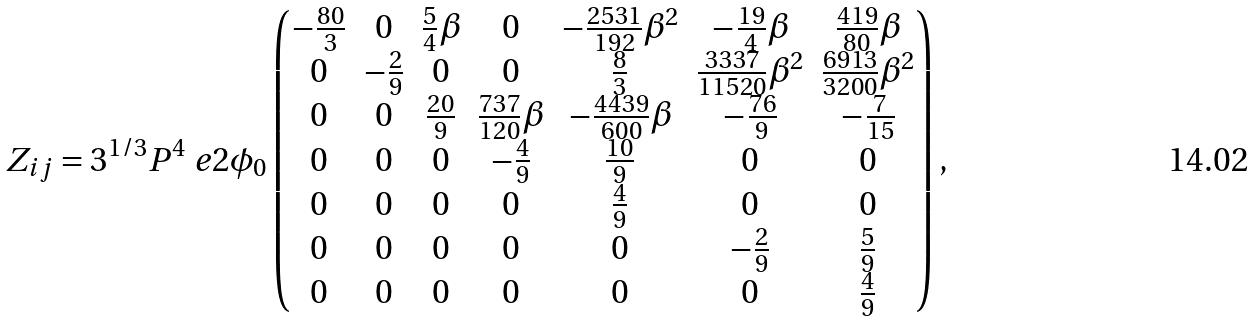Convert formula to latex. <formula><loc_0><loc_0><loc_500><loc_500>Z _ { i j } = 3 ^ { 1 / 3 } P ^ { 4 } \ e { 2 \phi _ { 0 } } \begin{pmatrix} - \frac { 8 0 } { 3 } & 0 & \frac { 5 } { 4 } \beta & 0 & - \frac { 2 5 3 1 } { 1 9 2 } \beta ^ { 2 } & - \frac { 1 9 } { 4 } \beta & \frac { 4 1 9 } { 8 0 } \beta \\ 0 & - \frac { 2 } { 9 } & 0 & 0 & \frac { 8 } { 3 } & \frac { 3 3 3 7 } { 1 1 5 2 0 } \beta ^ { 2 } & \frac { 6 9 1 3 } { 3 2 0 0 } \beta ^ { 2 } \\ 0 & 0 & \frac { 2 0 } { 9 } & \frac { 7 3 7 } { 1 2 0 } \beta & - \frac { 4 4 3 9 } { 6 0 0 } \beta & - \frac { 7 6 } { 9 } & - \frac { 7 } { 1 5 } \\ 0 & 0 & 0 & - \frac { 4 } { 9 } & \frac { 1 0 } { 9 } & 0 & 0 \\ 0 & 0 & 0 & 0 & \frac { 4 } { 9 } & 0 & 0 \\ 0 & 0 & 0 & 0 & 0 & - \frac { 2 } { 9 } & \frac { 5 } { 9 } \\ 0 & 0 & 0 & 0 & 0 & 0 & \frac { 4 } { 9 } \end{pmatrix} ,</formula> 